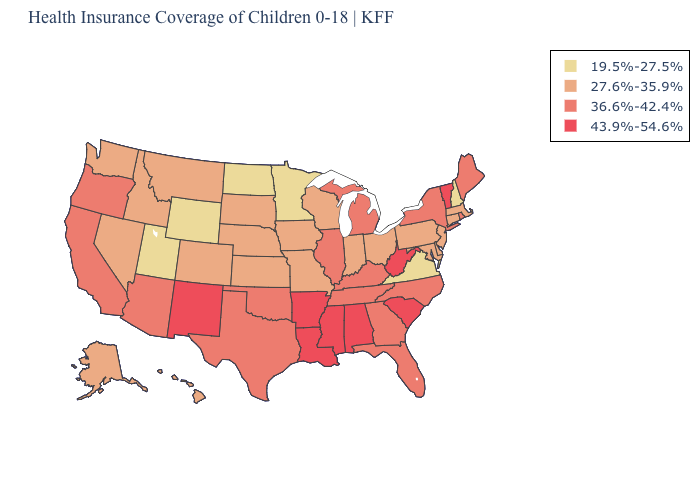Which states hav the highest value in the Northeast?
Write a very short answer. Vermont. Does the first symbol in the legend represent the smallest category?
Give a very brief answer. Yes. What is the value of Arizona?
Write a very short answer. 36.6%-42.4%. Does the first symbol in the legend represent the smallest category?
Answer briefly. Yes. Name the states that have a value in the range 36.6%-42.4%?
Concise answer only. Arizona, California, Florida, Georgia, Illinois, Kentucky, Maine, Michigan, New York, North Carolina, Oklahoma, Oregon, Rhode Island, Tennessee, Texas. Does the first symbol in the legend represent the smallest category?
Write a very short answer. Yes. Does Wyoming have the lowest value in the West?
Quick response, please. Yes. Name the states that have a value in the range 43.9%-54.6%?
Write a very short answer. Alabama, Arkansas, Louisiana, Mississippi, New Mexico, South Carolina, Vermont, West Virginia. Among the states that border Louisiana , does Arkansas have the highest value?
Short answer required. Yes. What is the lowest value in the USA?
Concise answer only. 19.5%-27.5%. What is the value of North Dakota?
Concise answer only. 19.5%-27.5%. What is the highest value in the USA?
Be succinct. 43.9%-54.6%. Name the states that have a value in the range 27.6%-35.9%?
Concise answer only. Alaska, Colorado, Connecticut, Delaware, Hawaii, Idaho, Indiana, Iowa, Kansas, Maryland, Massachusetts, Missouri, Montana, Nebraska, Nevada, New Jersey, Ohio, Pennsylvania, South Dakota, Washington, Wisconsin. Does Washington have the lowest value in the West?
Give a very brief answer. No. What is the value of Illinois?
Keep it brief. 36.6%-42.4%. 